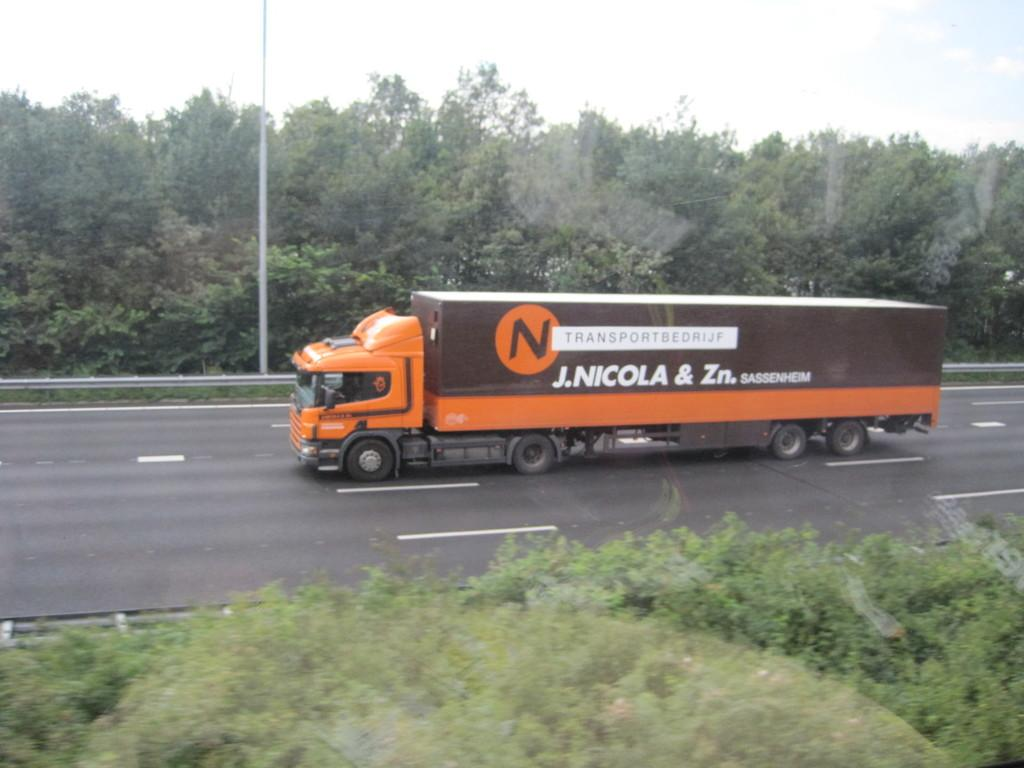What is on the road in the image? There is a vehicle on the road in the image. What type of natural elements can be seen in the image? There are trees and leaves present in the image. What structure can be seen in the image? There is a pole in the image. What is visible in the background of the image? The sky is visible in the background of the image. What type of pencil can be seen in the image? There is no pencil present in the image. What emotion is the vehicle experiencing in the image? Vehicles do not experience emotions, so this question cannot be answered. 